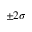Convert formula to latex. <formula><loc_0><loc_0><loc_500><loc_500>\pm 2 \sigma</formula> 